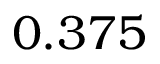Convert formula to latex. <formula><loc_0><loc_0><loc_500><loc_500>0 . 3 7 5</formula> 